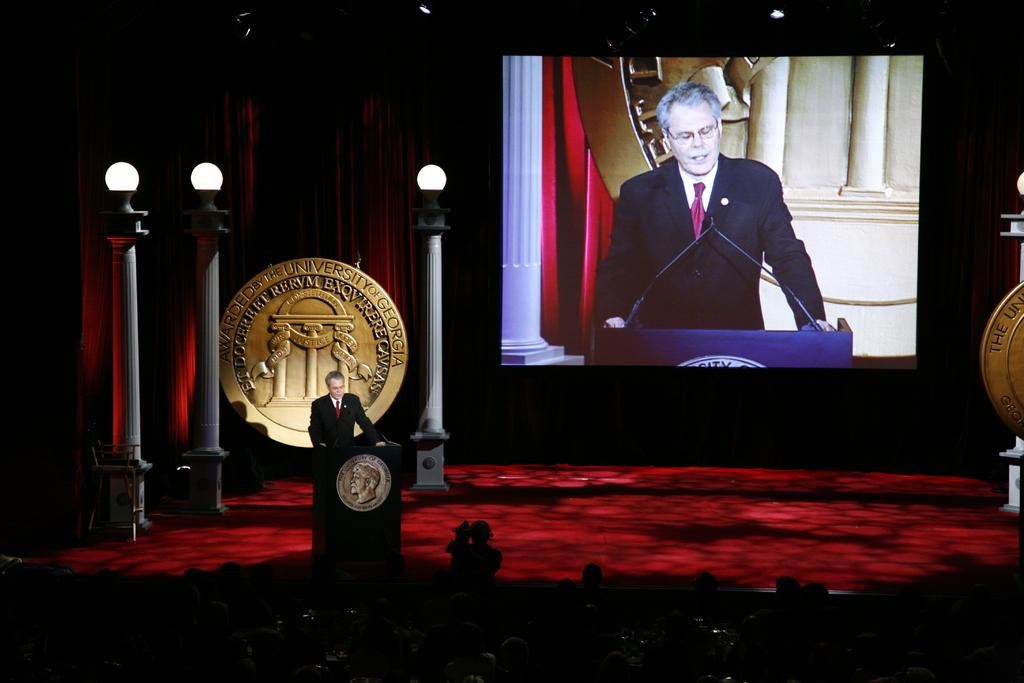Who is the main focus of the image? The main focus of the image is the person standing and speaking on the left side of the image. What is the setting of the image? The setting of the image is an audience at the bottom of the image. What is present at the back of the image? There is a screen visible at the back of the image. What type of house is visible in the image? There is no house present in the image. How does the person's haircut contribute to the overall message of the image? The image does not show the person's haircut, so it cannot be determined how it contributes to the overall message. 